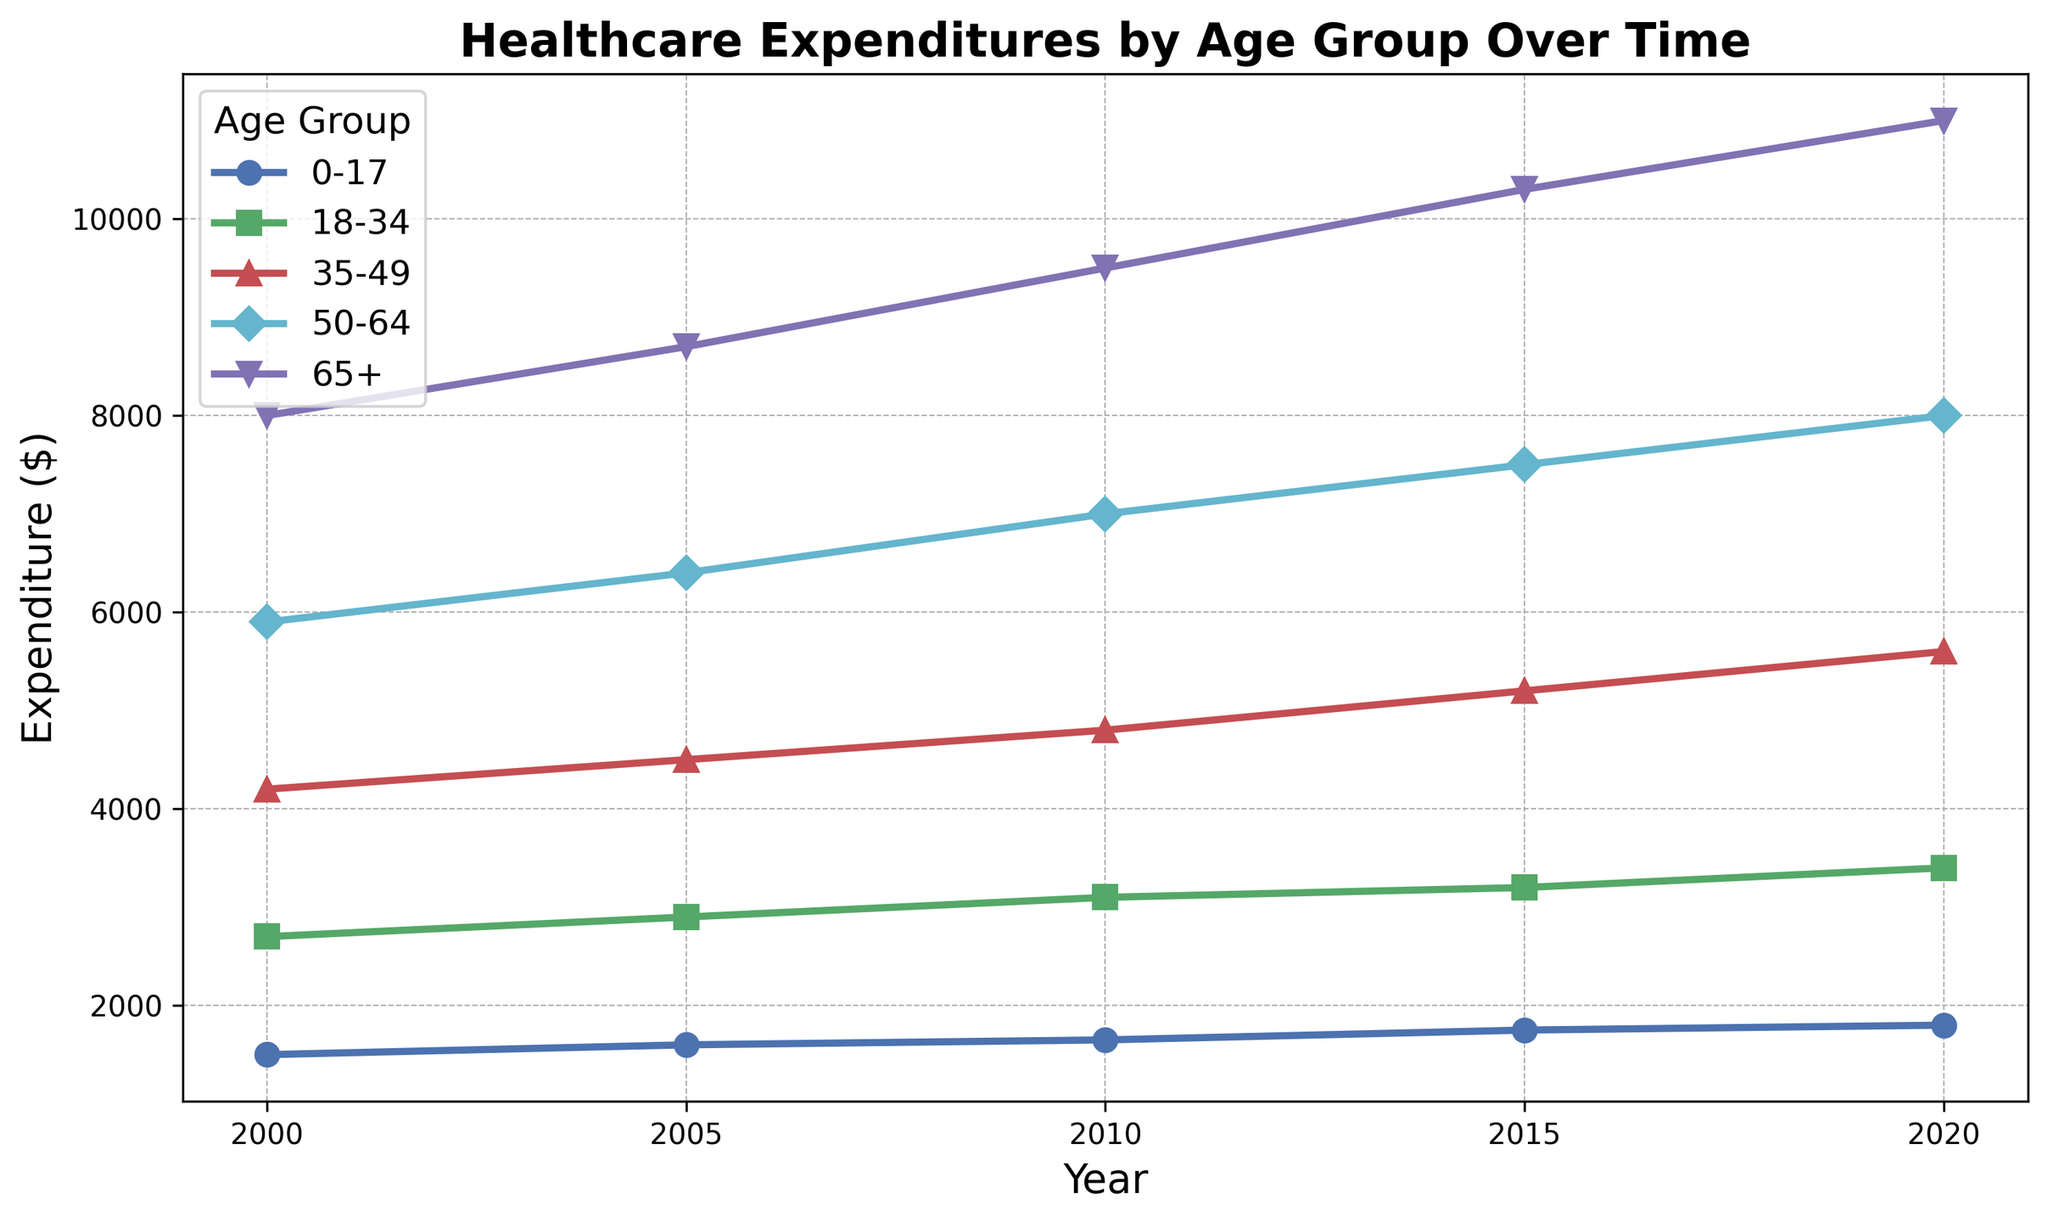What trend can be observed in healthcare expenditures for the 65+ age group from 2000 to 2020? To determine the trend, looking at the data points for the 65+ age group over the years 2000 to 2020, you can observe an increase from $8000 in 2000 to $11000 in 2020.
Answer: Expenditures increase Which age group had the highest healthcare expenditures in 2010? Observing the data points for 2010, the 65+ age group had expenditures of $9500, which is the highest compared to the other age groups.
Answer: 65+ What is the difference in healthcare expenditures between the 50-64 and 35-49 age groups in 2020? Subtract the expenditures of the 35-49 age group from the 50-64 age group in 2020. The expenditures are $8000 (50-64) and $5600 (35-49). $8000 - $5600 = $2400.
Answer: $2400 How did healthcare expenditures change for the 18-34 age group from 2000 to 2020? Comparing the expenditures in 2000 and 2020 for the 18-34 age group, they rose from $2700 to $3400.
Answer: Increased by $700 In which year did the 50-64 age group see the largest increase in healthcare expenditures? Compare the yearly increases for the 50-64 age group's expenditures: From 2000 to 2005: +$500, from 2005 to 2010: +$600, from 2010 to 2015: +$500, from 2015 to 2020: +$500. The largest increase is between 2005 and 2010.
Answer: Between 2005 and 2010 What is the average healthcare expenditure for the 0-17 age group over all years displayed? Sum the expenditures for the 0-17 age group from each year, and then divide by the number of years. ($1500 + $1600 + $1650 + $1750 + $1800) / 5 = $1660
Answer: $1660 Which age group had the smallest relative increase in healthcare expenditures from 2000 to 2020? Calculate the percentage increase for each age group by comparing expenditures in 2000 and 2020. The age group with the smallest percentage increase would be the one with the smallest difference between the start and end points relative to its initial value. The calculations show: 
0-17: ((1800-1500)/1500) * 100 = 20%
18-34: ((3400-2700)/2700) * 100 = 25.9%
35-49: ((5600-4200)/4200) * 100 = 33.3%
50-64: ((8000-5900)/5900) * 100 = 35.6%
65+: ((11000-8000)/8000) * 100 = 37.5%
Therefore, 0-17 has the smallest relative increase.
Answer: 0-17 In which year was the difference in healthcare expenditures between the 35-49 and 18-34 age groups the greatest? Calculate the differences between the 35-49 and 18-34 age groups for each year: 
2000: $4200 - $2700 = $1500, 
2005: $4500 - $2900 = $1600, 
2010: $4800 - $3100 = $1700, 
2015: $5200 - $3200 = $2000, 
2020: $5600 - $3400 = $2200. 
The year with the greatest difference is 2020 with $2200.
Answer: 2020 What is the total healthcare expenditure for all age groups combined in the year 2015? Sum up the expenditures for all age groups in 2015: $1750 + $3200 + $5200 + $7500 + $10300 = $27950.
Answer: $27950 How do the trends in healthcare expenditures for the 18-34 age group compare visually to those of the 50-64 age group from 2000 to 2020? Visually, the expenditure for the 50-64 age group shows a much steeper upward trend compared to the 18-34 age group, which has a more gradual increase over the same period.
Answer: 50-64 steeper increase 